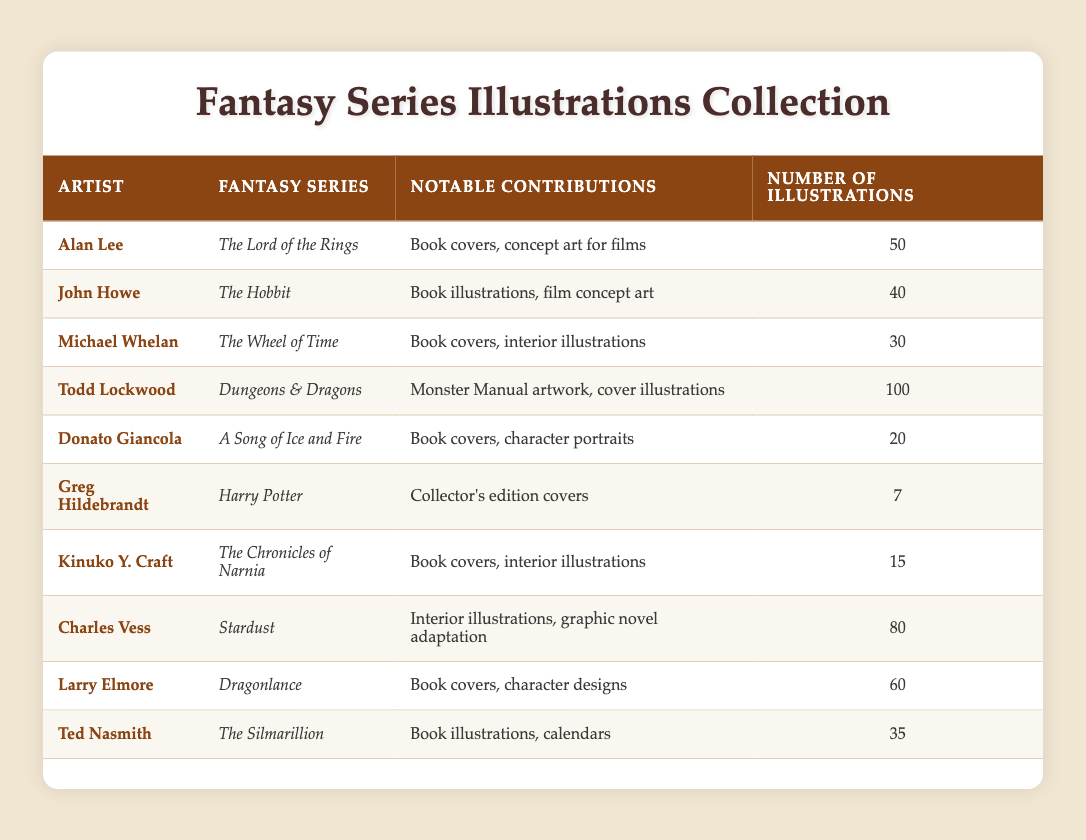What is the notable contribution of Todd Lockwood? Todd Lockwood's notable contributions include Monster Manual artwork and cover illustrations for Dungeons & Dragons. This information is listed in the third column for the row corresponding to Todd Lockwood.
Answer: Monster Manual artwork, cover illustrations Which artist contributed the least number of illustrations? To find the artist with the least number of illustrations, we look at the fourth column of the table. The minimum value is 7, which corresponds to Greg Hildebrandt.
Answer: Greg Hildebrandt How many illustrations were contributed by artists who worked on "The Lord of the Rings" and "The Hobbit"? Alan Lee contributed 50 illustrations for "The Lord of the Rings" and John Howe contributed 40 illustrations for "The Hobbit." The sum of these numbers is 50 + 40 = 90.
Answer: 90 Is Donato Giancola the artist with the highest number of illustrations in the table? The highest number of illustrations is 100, contributed by Todd Lockwood. Since Donato Giancola has only 20 illustrations, the statement is false.
Answer: No What percentage of the total illustrations were created by Charles Vess? First, we calculate the total number of illustrations: 50 + 40 + 30 + 100 + 20 + 7 + 15 + 80 + 60 + 35 = 442. Charles Vess contributed 80 illustrations, so the percentage is (80 / 442) * 100 ≈ 18.1%.
Answer: 18.1% 